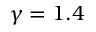Convert formula to latex. <formula><loc_0><loc_0><loc_500><loc_500>\gamma = 1 . 4</formula> 